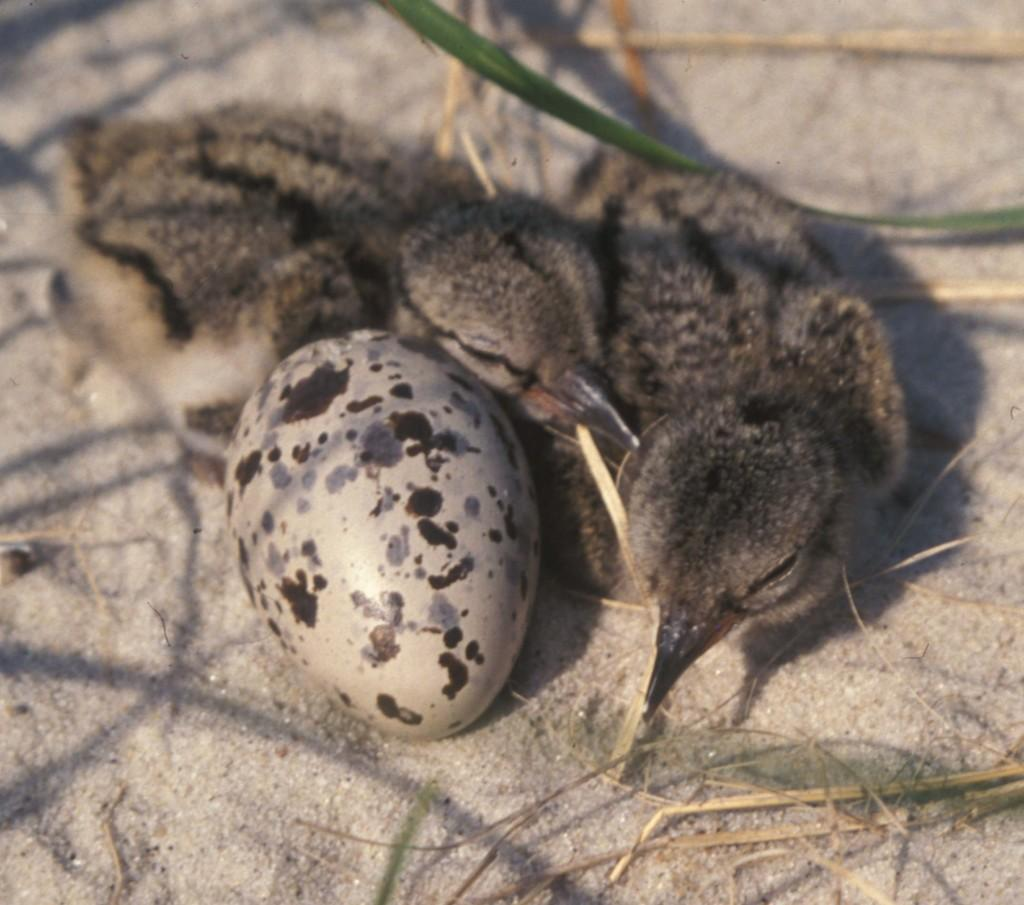How many birds are present in the image? There are two birds in the image. What else can be seen in the image besides the birds? There is an egg in the image. Where are the birds and the egg located? They are on a surface in the image. What type of crook is visible in the image? There is no crook present in the image. Can you tell me the length of the cord in the image? There is no cord present in the image. 